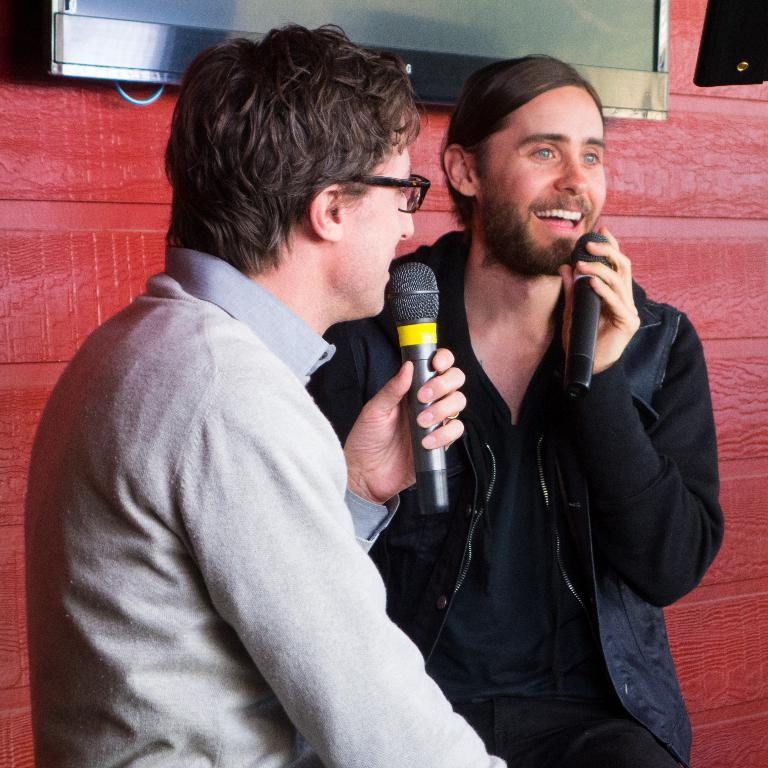How many people are in the image? There are two men in the image. Can you describe the appearance of one of the men? One man is wearing a black jacket and smiling. What is the other man holding in the image? The other man is holding a microphone. What can be seen in the background of the image? There is a TV and a wall in the background of the image. What type of fuel is being used by the scale in the image? There is no scale present in the image, and therefore no fuel is being used. 